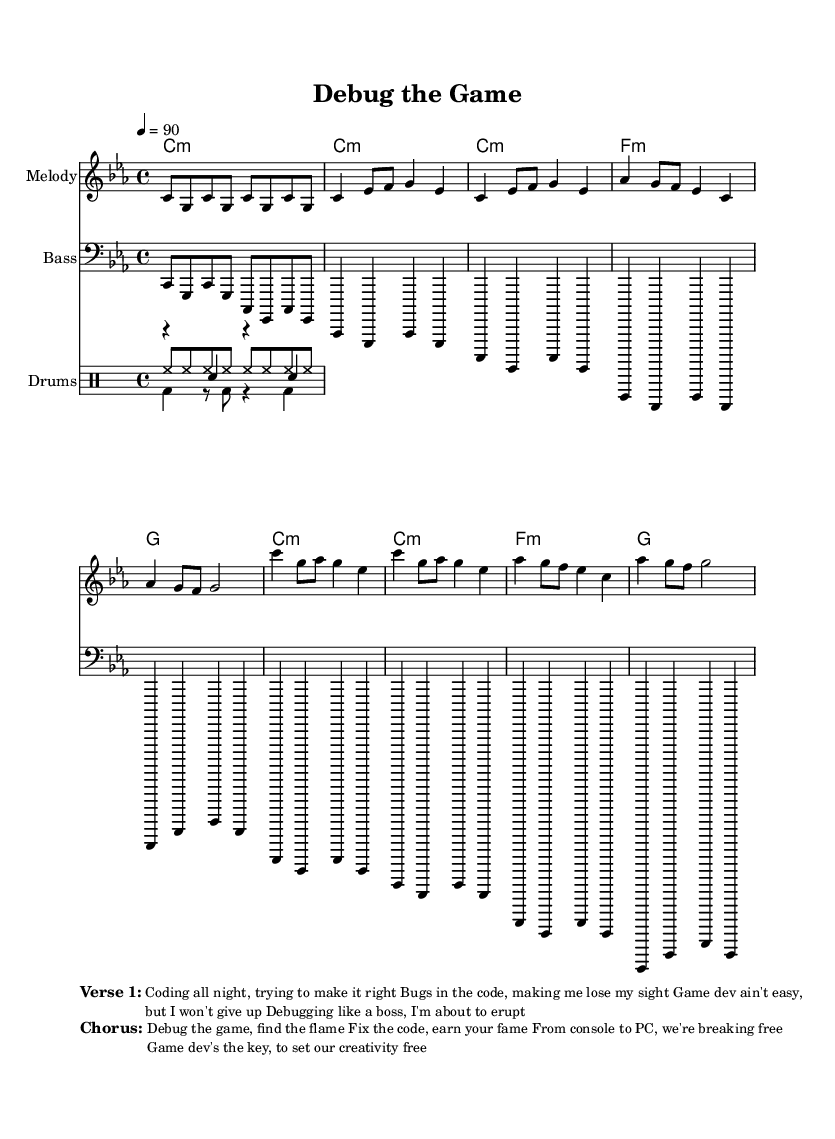What is the key signature of this music? The key signature is C minor, which contains three flats (B♭, E♭, A♭). It can be identified by looking at the clef and the symbols at the beginning of the staff.
Answer: C minor What is the time signature of this music? The time signature is 4/4, indicated by the "4 over 4" notation at the beginning of the score. This means there are four beats per measure and the quarter note gets one beat.
Answer: 4/4 What is the tempo marking of this music? The tempo marking indicates a speed of 90 beats per minute, which is specified by "4 = 90". This represents the tempo setting for the piece.
Answer: 90 How many measures does the chorus have? The chorus consists of four measures, which can be counted from the corresponding section in the sheet music after identifying the distinct lines for melody and harmony.
Answer: 4 What elements are used in the drum section? The drum section consists of kick drum, snare drum, and hi-hat, as listed under the respective drum voices in the score. Each element has its own rhythmic pattern, indicating how they will be played.
Answer: Kick, snare, hi-hat What is the lyrical focus of the first verse? The first verse focuses on the struggles of coding and debugging in game development, highlighting the challenges faced while trying to fix bugs. This can be inferred from the content written below the staff.
Answer: Coding challenges What theme does the chorus convey? The chorus conveys a theme of empowerment and creative freedom in game development, encouraging fixing code to earn success and break free from limitations. This is evident from the phrasing found in the chorus lyrics.
Answer: Debugging for creativity 